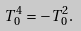<formula> <loc_0><loc_0><loc_500><loc_500>T ^ { 4 } _ { 0 } = - T ^ { 2 } _ { 0 } .</formula> 